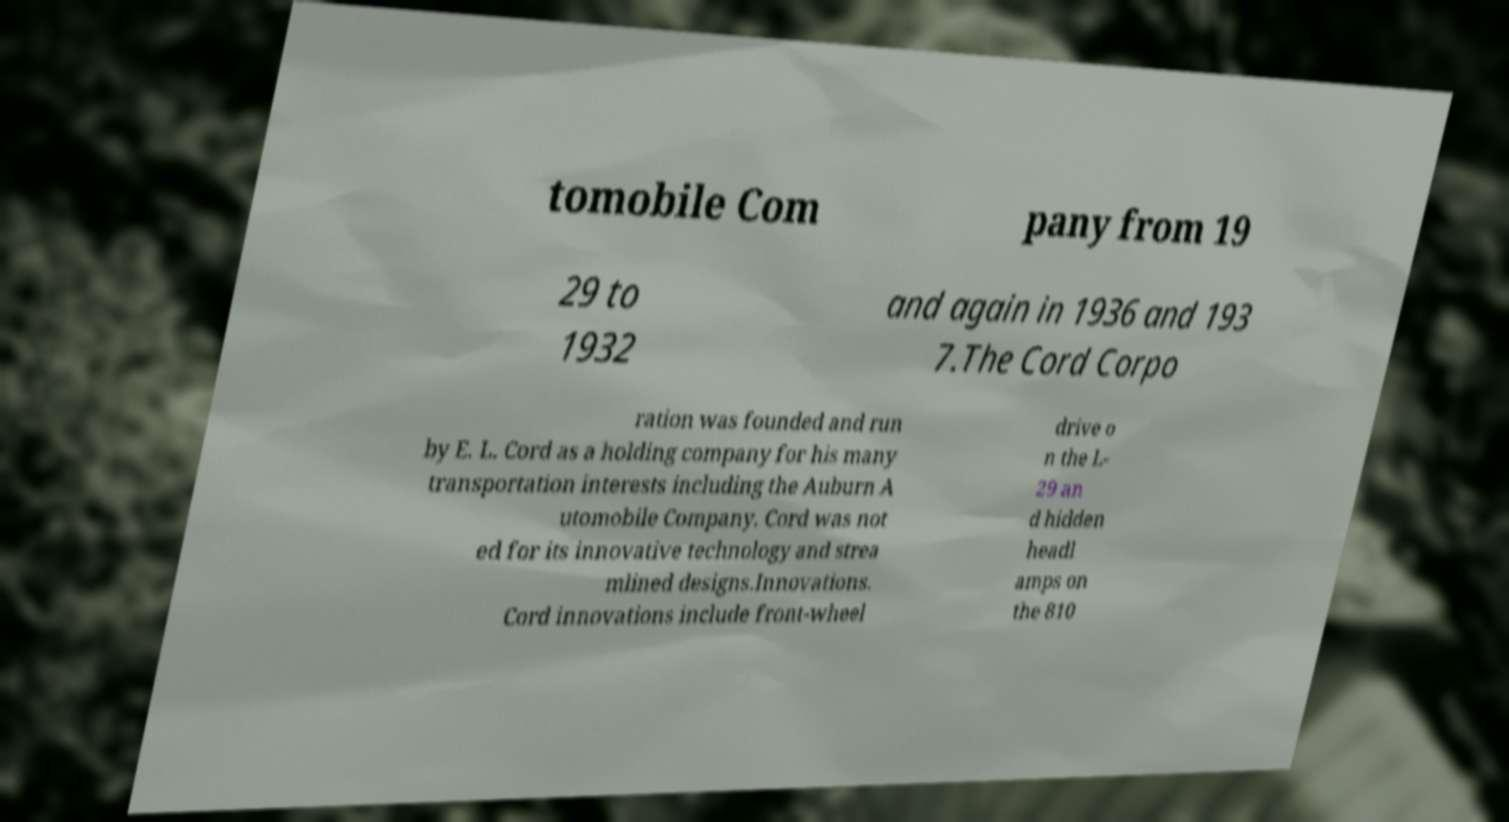There's text embedded in this image that I need extracted. Can you transcribe it verbatim? tomobile Com pany from 19 29 to 1932 and again in 1936 and 193 7.The Cord Corpo ration was founded and run by E. L. Cord as a holding company for his many transportation interests including the Auburn A utomobile Company. Cord was not ed for its innovative technology and strea mlined designs.Innovations. Cord innovations include front-wheel drive o n the L- 29 an d hidden headl amps on the 810 